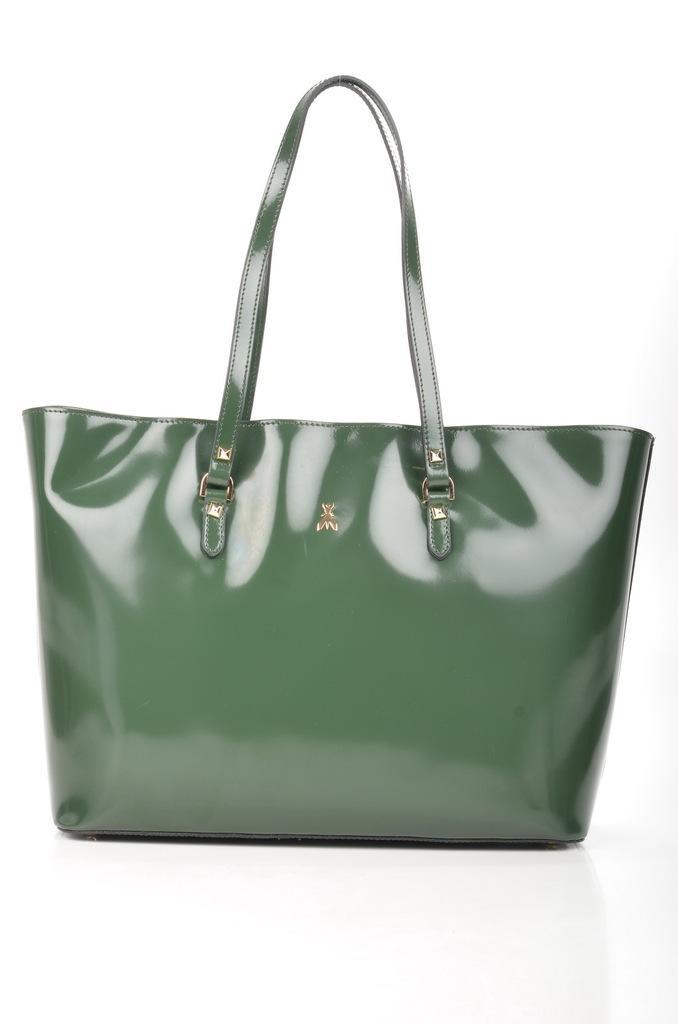In one or two sentences, can you explain what this image depicts? It is a green color bag ,ladies bag it is kept on a white color floor,the background is also white color. 